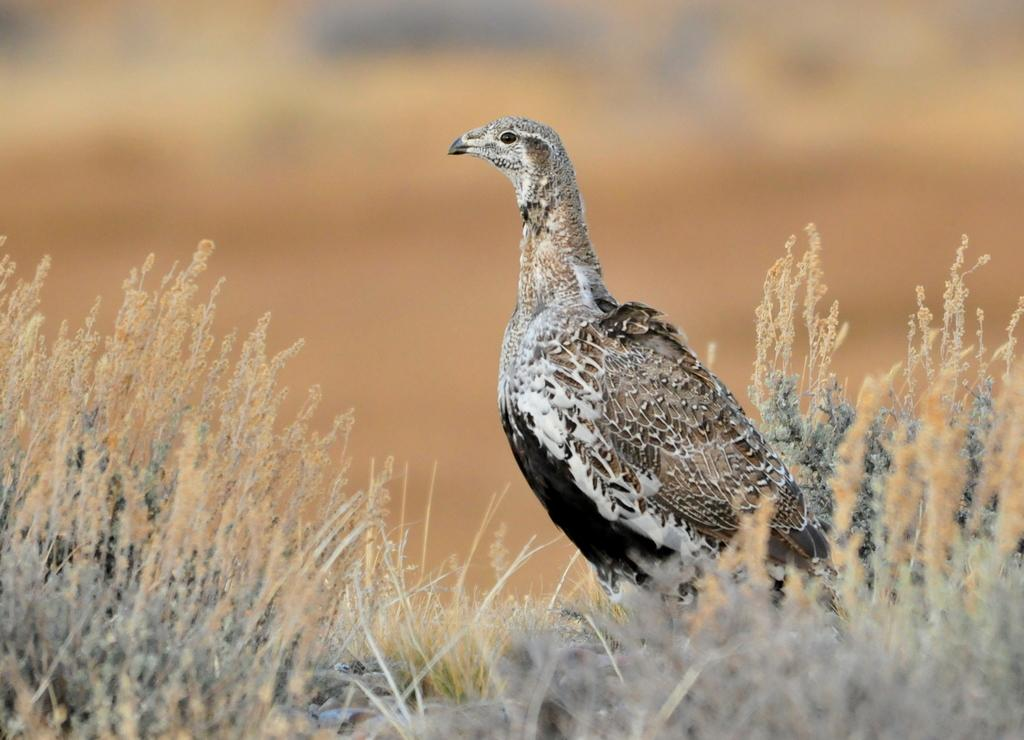What type of animal is in the image? There is a bird in the image. Where is the bird located? The bird is on the grass. Can you describe the background of the image? The background of the image is blurred. What harbor can be seen in the background of the image? There is no harbor present in the image; the background is blurred. Can you tell me how the man is interacting with the bird in the image? There is no man present in the image, only a bird on the grass. 